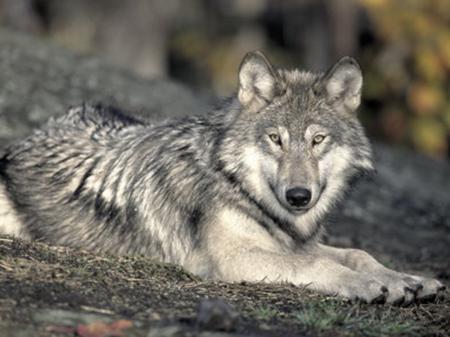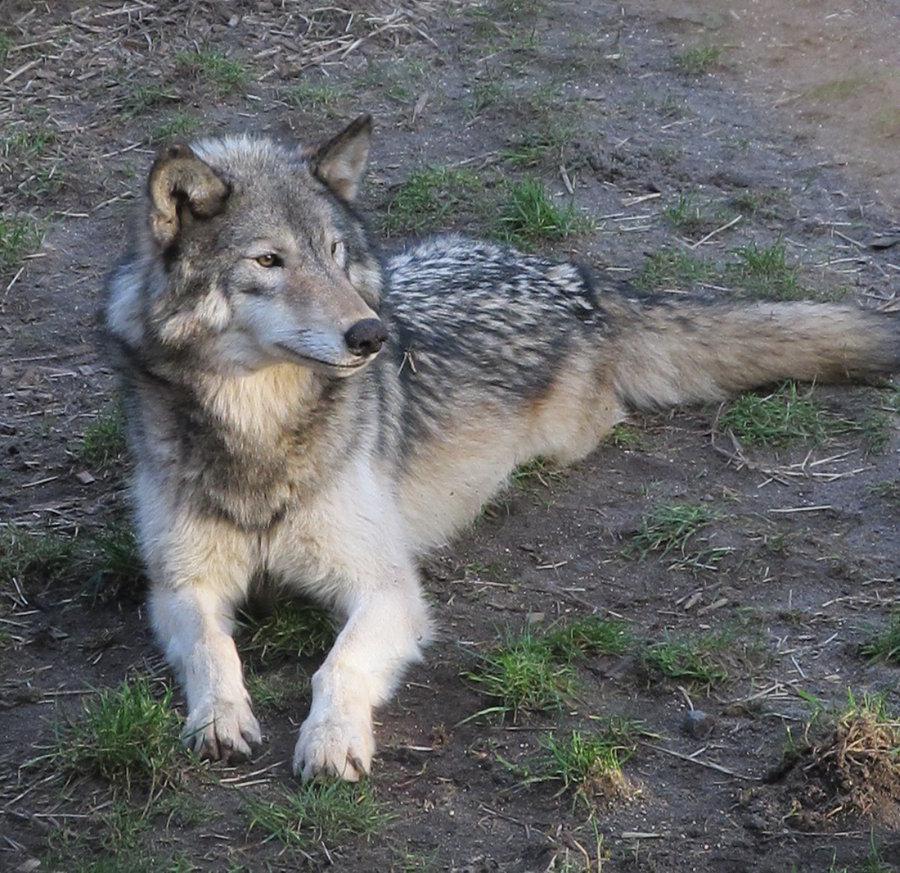The first image is the image on the left, the second image is the image on the right. Considering the images on both sides, is "Both wolves are lying down and one is laying it's head on it's legs." valid? Answer yes or no. No. The first image is the image on the left, the second image is the image on the right. For the images shown, is this caption "One wolf's teeth are visible." true? Answer yes or no. No. 